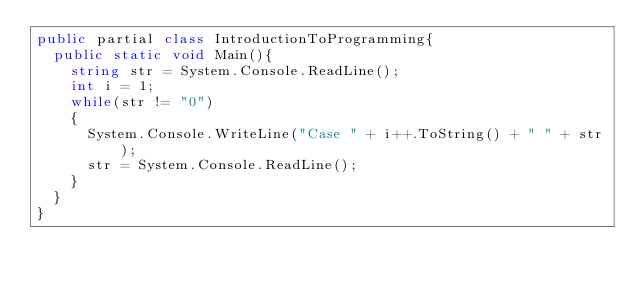Convert code to text. <code><loc_0><loc_0><loc_500><loc_500><_C#_>public partial class IntroductionToProgramming{
	public static void Main(){
		string str = System.Console.ReadLine();
		int i = 1;
		while(str != "0")
		{
			System.Console.WriteLine("Case " + i++.ToString() + " " + str);
			str = System.Console.ReadLine();
		}
	}
}</code> 